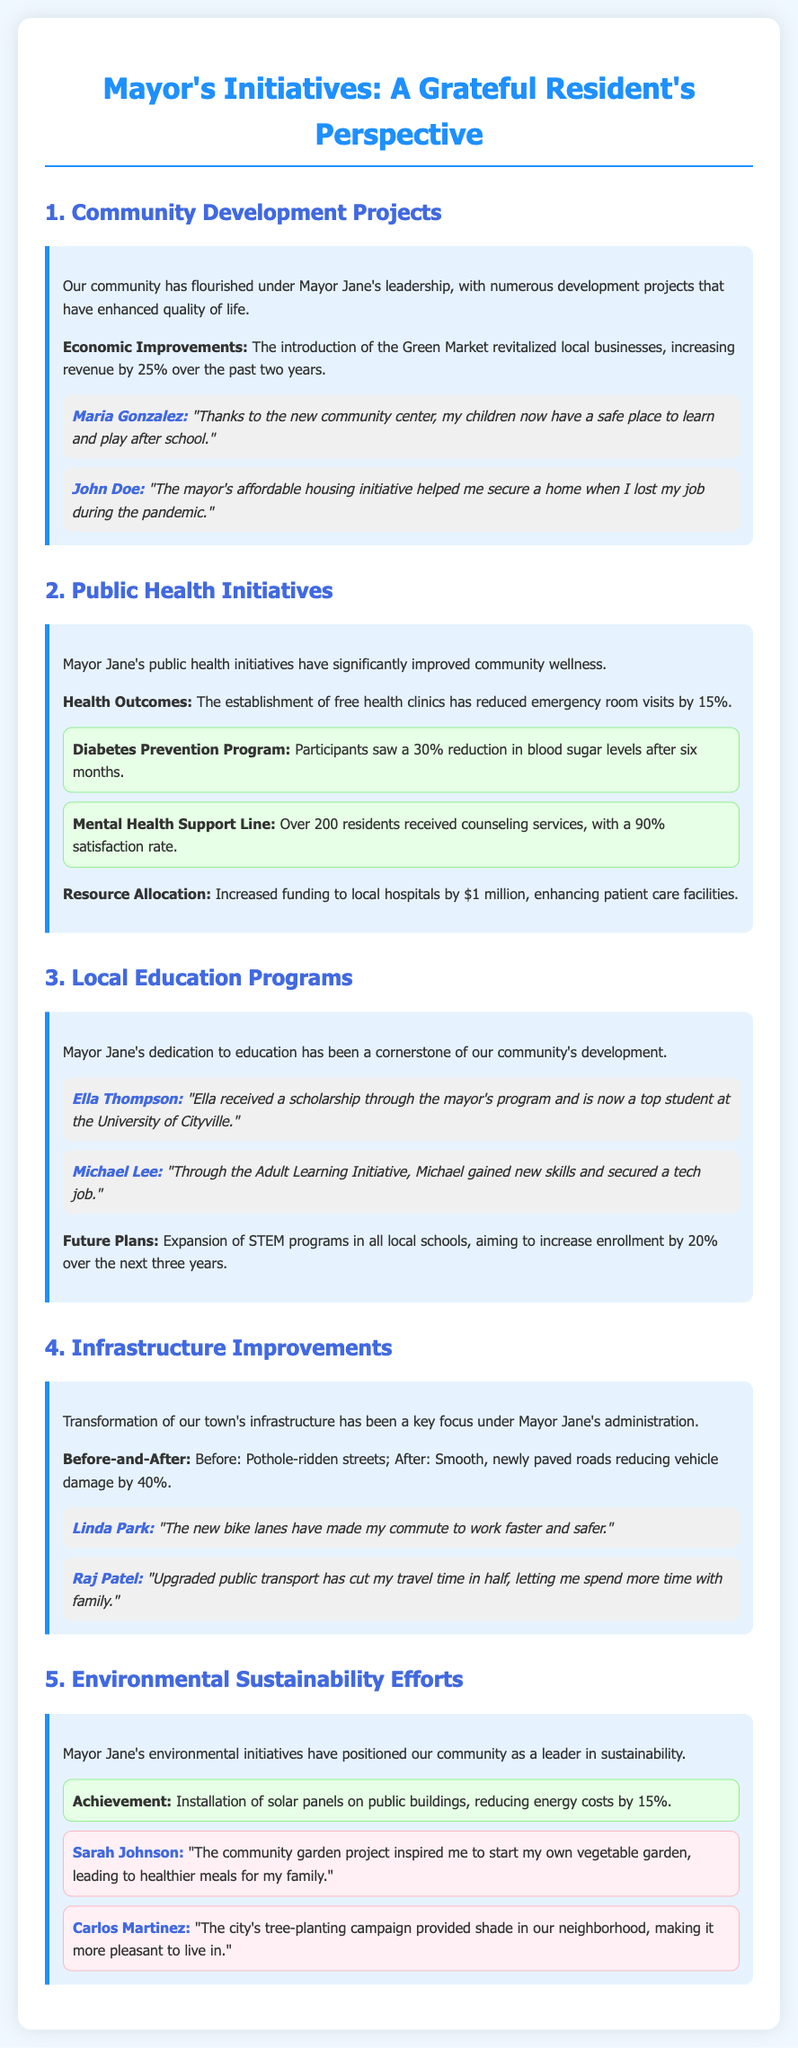What is the revenue increase from the Green Market? The document states that the Green Market has increased revenue by 25% over the past two years.
Answer: 25% What program helped to reduce emergency room visits by 15%? The establishment of free health clinics has contributed to the reduction of emergency room visits by 15%.
Answer: Free health clinics Who received a scholarship through the mayor's program? Ella Thompson is mentioned as the recipient of a scholarship through the mayor's program.
Answer: Ella Thompson What percentage of residents expressed satisfaction with the Mental Health Support Line? A 90% satisfaction rate is reported for the Mental Health Support Line services.
Answer: 90% What future plan aims to increase STEM enrollment by 20%? The expansion of STEM programs in local schools aims to increase enrollment by 20% over the next three years.
Answer: Expansion of STEM programs What specific achievement reduced energy costs by 15%? The installation of solar panels on public buildings has reduced energy costs by 15%.
Answer: Installation of solar panels Which resident mentioned the commuting benefits of new bike lanes? Linda Park noted that the new bike lanes improved her commute.
Answer: Linda Park What is the focus of the mayor's infrastructure improvements? The document emphasizes the transformation of the town's infrastructure.
Answer: Infrastructure improvements What was the improvement of vehicle damage after road paving? The newly paved roads reduced vehicle damage by 40%.
Answer: 40% 